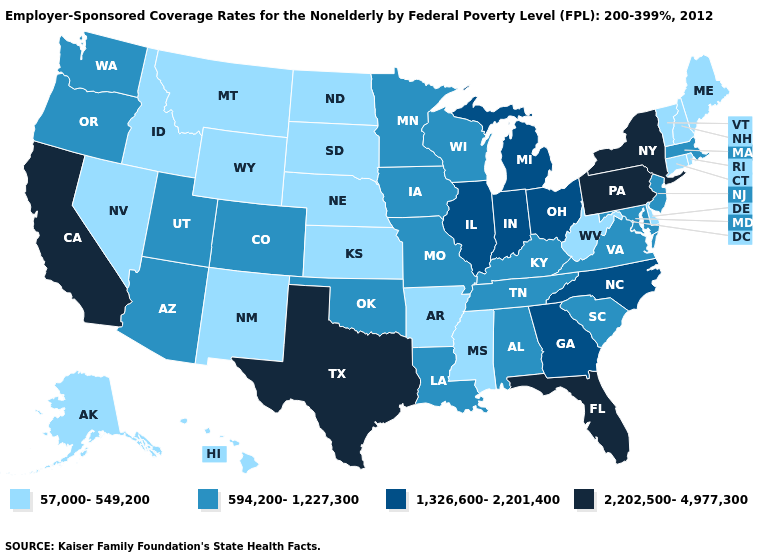Which states have the lowest value in the USA?
Keep it brief. Alaska, Arkansas, Connecticut, Delaware, Hawaii, Idaho, Kansas, Maine, Mississippi, Montana, Nebraska, Nevada, New Hampshire, New Mexico, North Dakota, Rhode Island, South Dakota, Vermont, West Virginia, Wyoming. What is the value of Colorado?
Concise answer only. 594,200-1,227,300. Which states have the highest value in the USA?
Write a very short answer. California, Florida, New York, Pennsylvania, Texas. Name the states that have a value in the range 57,000-549,200?
Keep it brief. Alaska, Arkansas, Connecticut, Delaware, Hawaii, Idaho, Kansas, Maine, Mississippi, Montana, Nebraska, Nevada, New Hampshire, New Mexico, North Dakota, Rhode Island, South Dakota, Vermont, West Virginia, Wyoming. Among the states that border Nevada , does California have the highest value?
Concise answer only. Yes. Does Alabama have a higher value than Florida?
Be succinct. No. Does Nebraska have the lowest value in the MidWest?
Give a very brief answer. Yes. Name the states that have a value in the range 2,202,500-4,977,300?
Give a very brief answer. California, Florida, New York, Pennsylvania, Texas. What is the lowest value in states that border California?
Be succinct. 57,000-549,200. Does the map have missing data?
Give a very brief answer. No. Which states have the lowest value in the USA?
Write a very short answer. Alaska, Arkansas, Connecticut, Delaware, Hawaii, Idaho, Kansas, Maine, Mississippi, Montana, Nebraska, Nevada, New Hampshire, New Mexico, North Dakota, Rhode Island, South Dakota, Vermont, West Virginia, Wyoming. What is the value of Oklahoma?
Quick response, please. 594,200-1,227,300. Does Vermont have the same value as North Carolina?
Write a very short answer. No. Among the states that border Nebraska , which have the highest value?
Keep it brief. Colorado, Iowa, Missouri. Is the legend a continuous bar?
Quick response, please. No. 